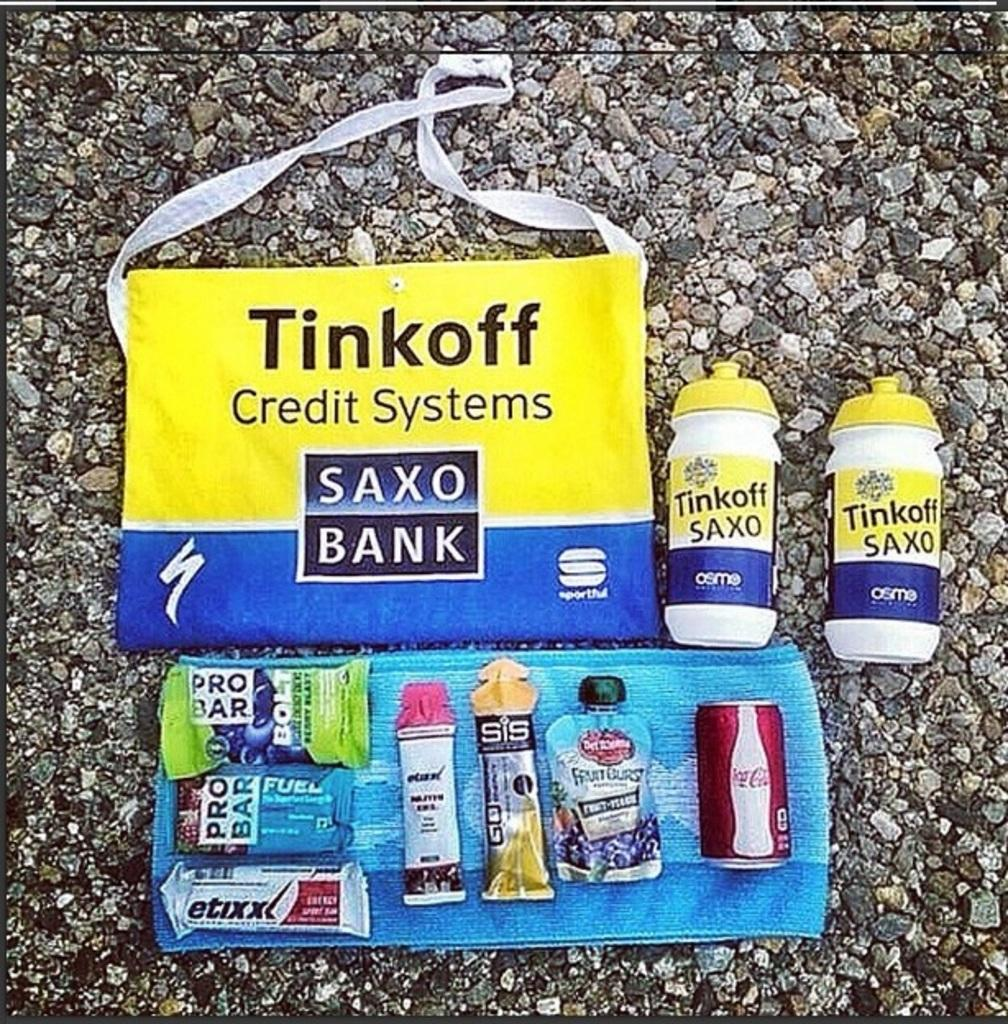What is the name of the bag in the image? The bag is labelled with the name "Tinkoff". What else in the image has the same label as the bag? The two plastic containers in the image are also labelled with the name "Tinkoff". What type of food items can be seen in the image? There are protein bars and a coke tin in the image. How are the eatables arranged in the image? The eatables are placed on a napkin in the image. How many letters are visible in the image? There is no information about letters in the image, as the focus is on the bag, containers, and food items. 